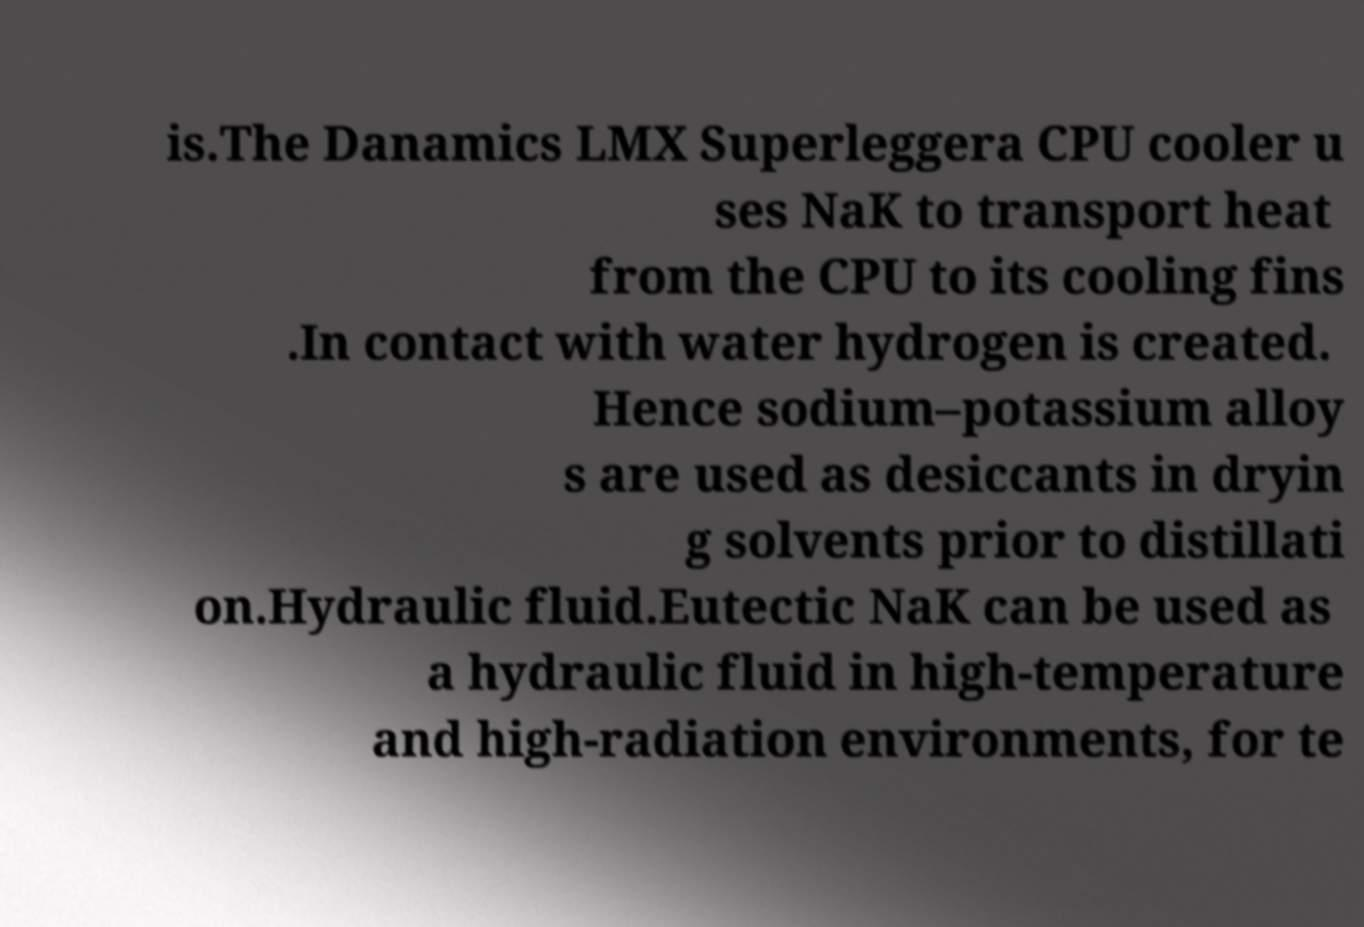Please read and relay the text visible in this image. What does it say? is.The Danamics LMX Superleggera CPU cooler u ses NaK to transport heat from the CPU to its cooling fins .In contact with water hydrogen is created. Hence sodium–potassium alloy s are used as desiccants in dryin g solvents prior to distillati on.Hydraulic fluid.Eutectic NaK can be used as a hydraulic fluid in high-temperature and high-radiation environments, for te 